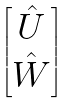Convert formula to latex. <formula><loc_0><loc_0><loc_500><loc_500>\begin{bmatrix} \hat { U } \\ \hat { W } \end{bmatrix}</formula> 